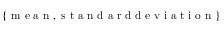<formula> <loc_0><loc_0><loc_500><loc_500>\{ m e a n , s t a n d a r d d e v i a t i o n \}</formula> 